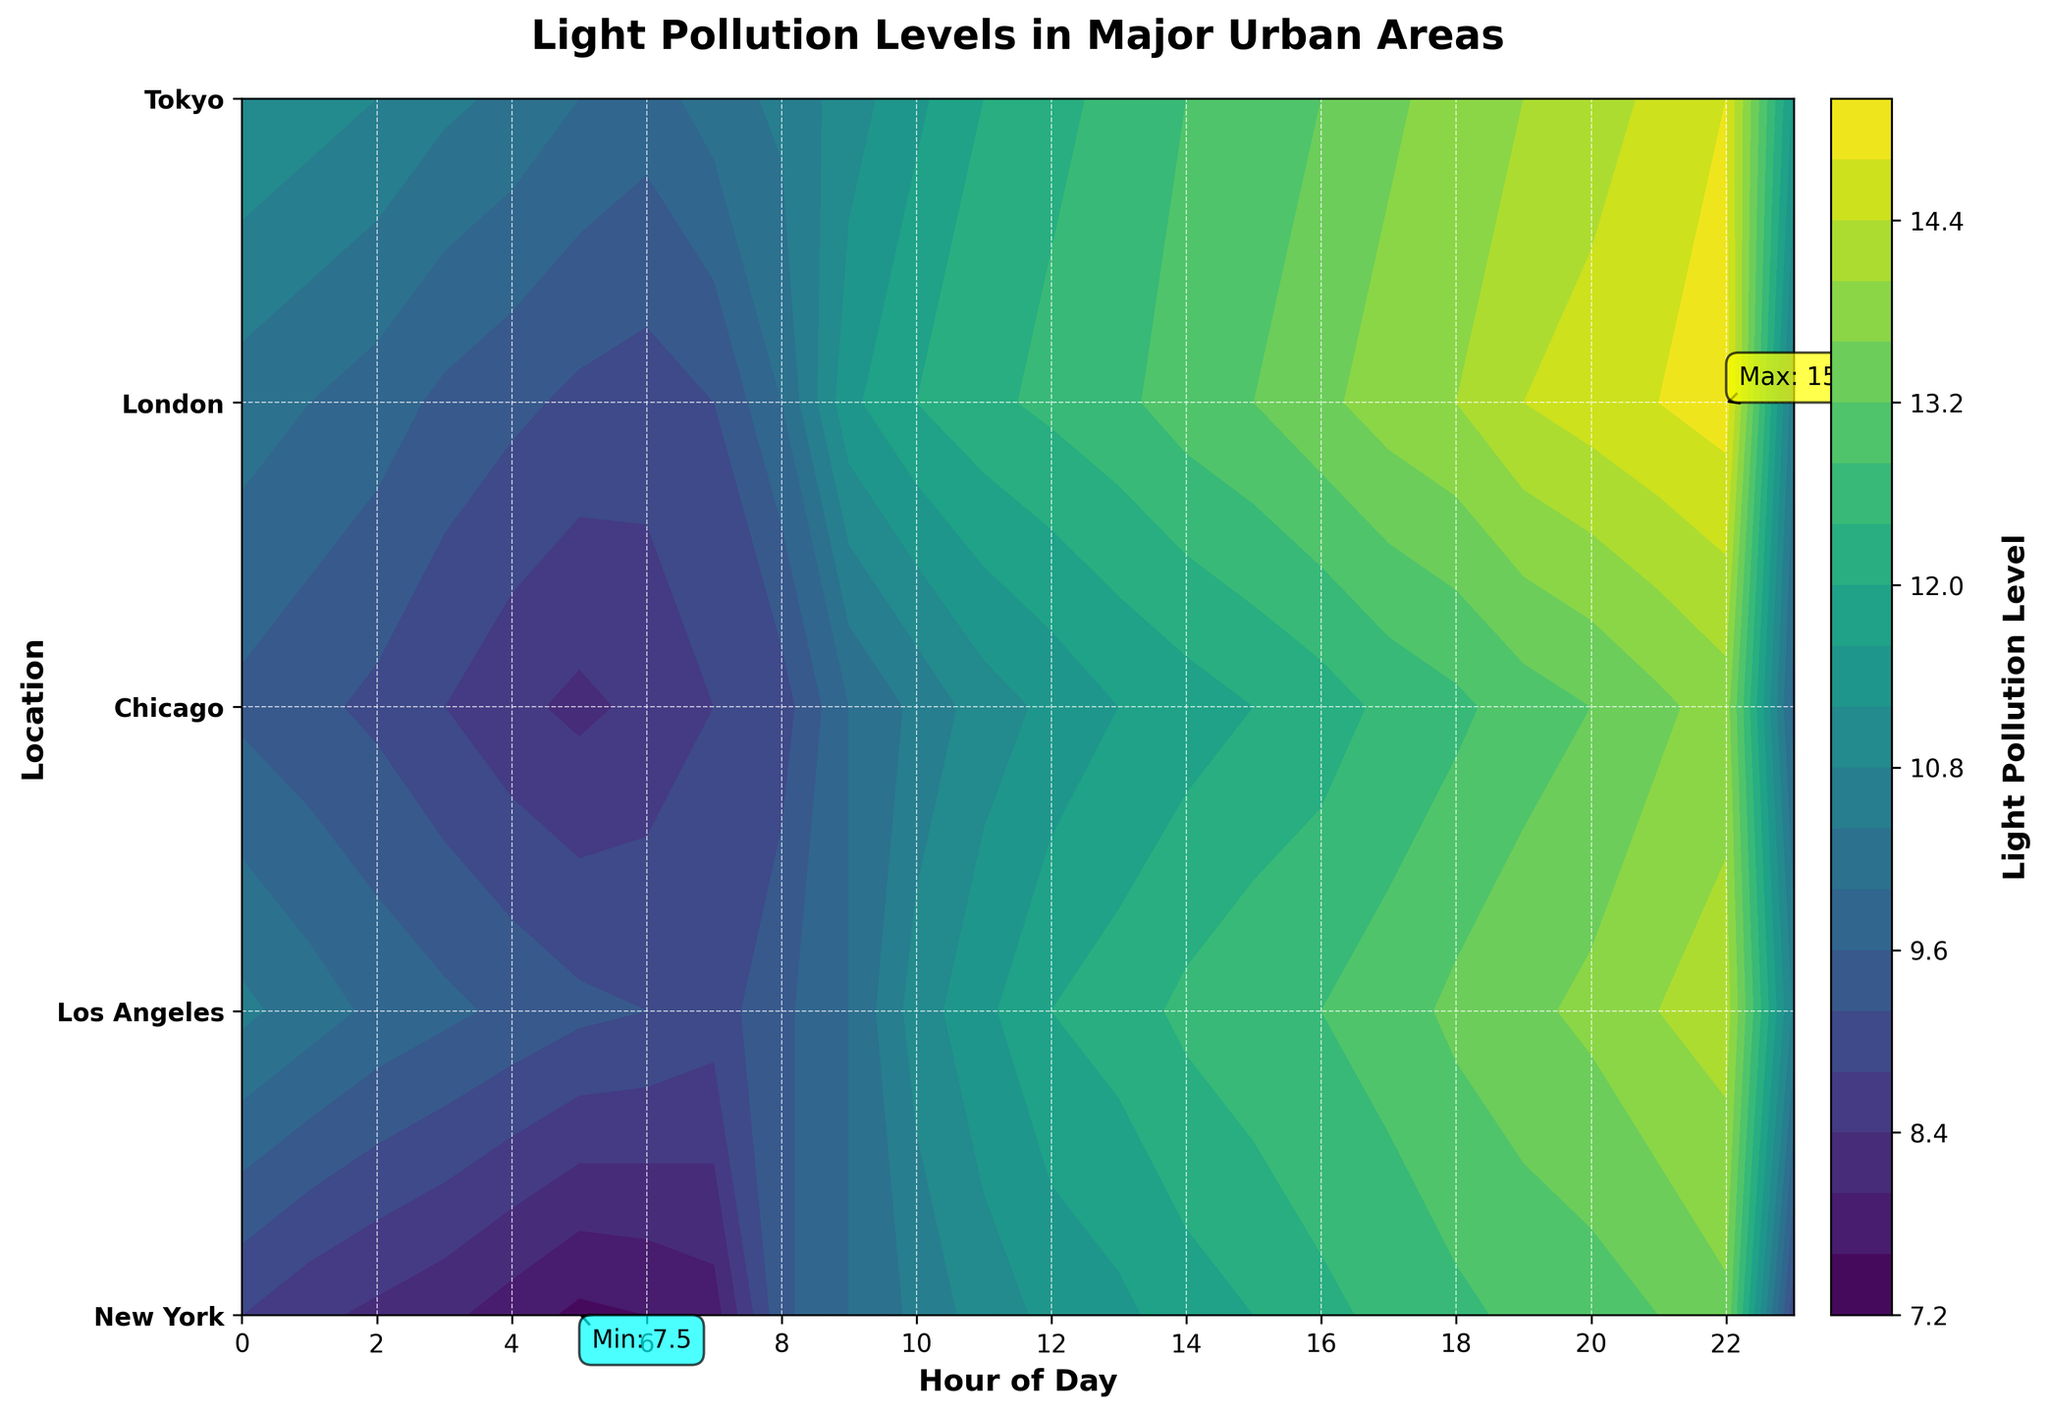What is the title of the contour plot? The title of the contour plot is displayed at the top of the figure which reads 'Light Pollution Levels in Major Urban Areas'.
Answer: Light Pollution Levels in Major Urban Areas What information is displayed on the x-axis? The x-axis of the contour plot shows the 'Hour of Day', with ticks labeled in a 24-hour format, marked in intervals of 2 hours (e.g., 0, 2, 4, ..., 22).
Answer: Hour of Day What do the different colors in the contour plot represent? The colors in the contour plot represent varying levels of light pollution. A color bar to the right of the plot provides a gradient scale indicating the light pollution levels corresponding to each color.
Answer: Light Pollution Levels How does the light pollution level in New York compare between 0 and 23 hours? To compare the light pollution levels, we look at the values at 0 and 23 hours in the row representing New York. At 0 hours, the light pollution level is 10.2, and at 23 hours, it is 10.5. Therefore, the level slightly increases from 0 to 23 hours.
Answer: Increasing Which city has the highest overall light pollution level, and what value does it reach? To find the highest overall light pollution level, we look at the annotations or the color intensity. The maximum value is marked on the plot, and from the annotation, we see that Tokyo reaches the highest level at 14.8.
Answer: Tokyo, 14.8 What is the minimum light pollution level in Chicago throughout the day? The minimum value for Chicago can be found by looking at the annotations on the plot. It is marked with a cyan annotation indicating that the lowest light pollution level in Chicago is 7.5, which occurs at 5 hours.
Answer: 7.5 Which two cities have the lightest pollution levels at 5 hours, and what are those levels? Reviewing the rows corresponding to 5 hours, we observe the values. New York has a level of 9.1, and Los Angeles has 8.3. The lightest pollution level at 5 hours is in Los Angeles at 8.3.
Answer: Los Angeles, 8.3 How are the light pollution levels distributed in Tokyo across different hours? Insight into Tokyo’s light pollution levels is obtained by viewing its row in the contour plot. Level ranges from 9.8 to 14.8. The distribution generally shows increasing levels through the day peaking before midnight.
Answer: 9.8 to 14.8, increasing At what hours does London experience significant changes in light pollution levels? To determine significant changes, examine the contour areas for sudden color shifts in London's row. Notable changes occur around 10 hours (increasing) and 20 hours (peaking).
Answer: 10 hours, 20 hours 